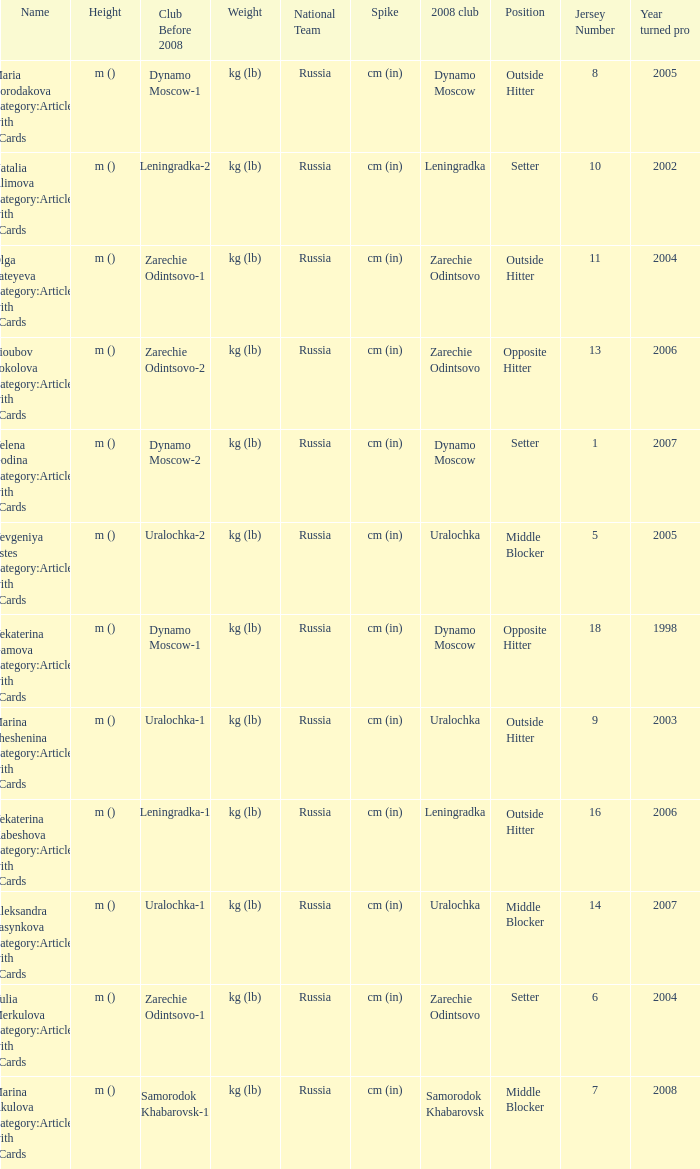What is the name when the 2008 club is zarechie odintsovo? Olga Fateyeva Category:Articles with hCards, Lioubov Sokolova Category:Articles with hCards, Yulia Merkulova Category:Articles with hCards. 